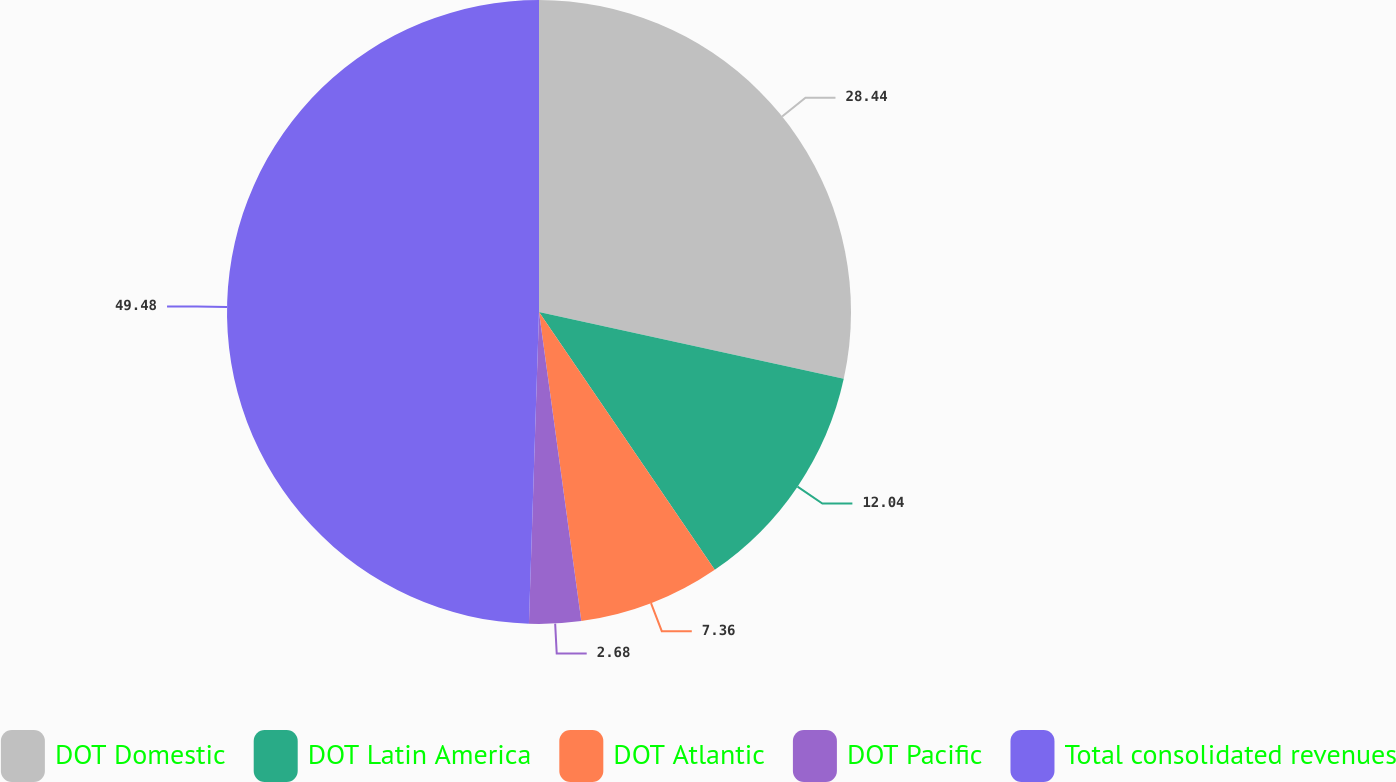Convert chart. <chart><loc_0><loc_0><loc_500><loc_500><pie_chart><fcel>DOT Domestic<fcel>DOT Latin America<fcel>DOT Atlantic<fcel>DOT Pacific<fcel>Total consolidated revenues<nl><fcel>28.44%<fcel>12.04%<fcel>7.36%<fcel>2.68%<fcel>49.49%<nl></chart> 